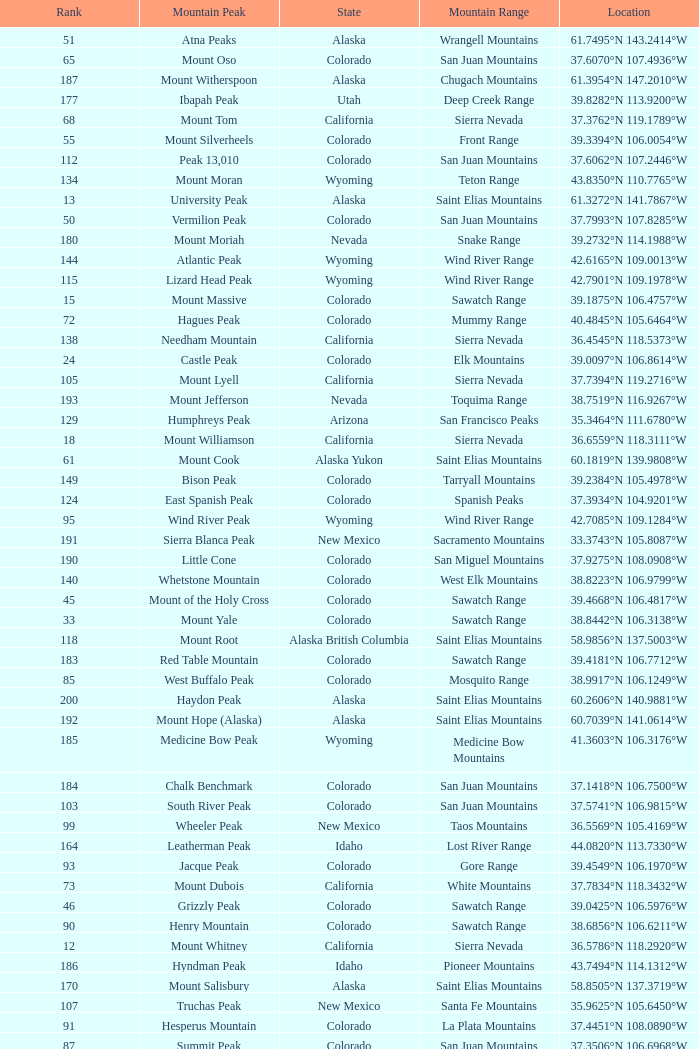What is the mountain peak when the location is 37.5775°n 105.4856°w? Blanca Peak. 